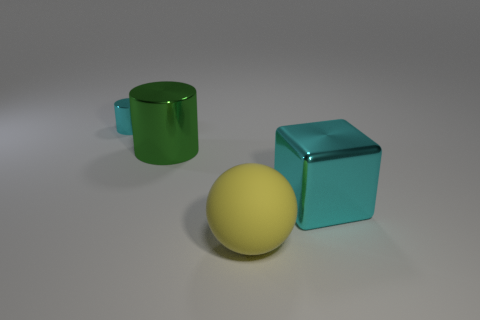What could be a potential use for these objects in a real-world setting? In a real-world context, the green cylinder might serve as a drinking vessel or a container for small items. The yellow rubber ball could be used for playing catch, recreational sports, or as a stress-relief squeeze toy. The cyan cube, depending on its material, could function as a paperweight, a decorative object, or an educational tool for teaching geometry. 